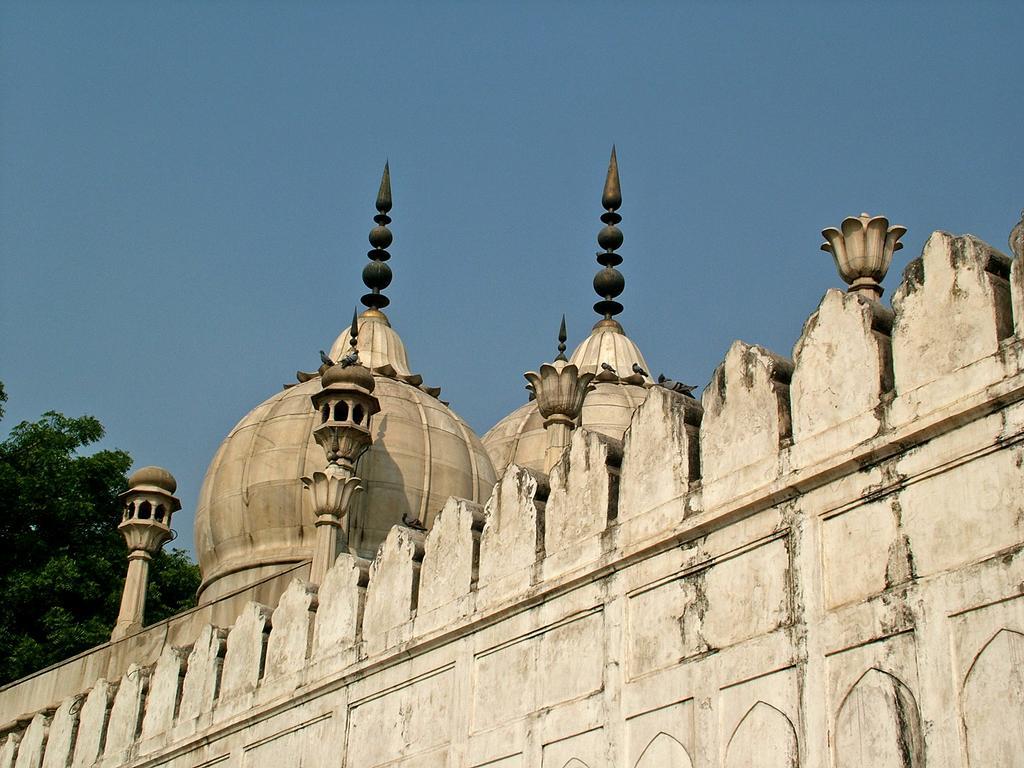Can you describe this image briefly? In the picture we can see a mosque, which is very old and behind it on the left hand side we can see trees and in the background we can see a sky which is blue in color. 